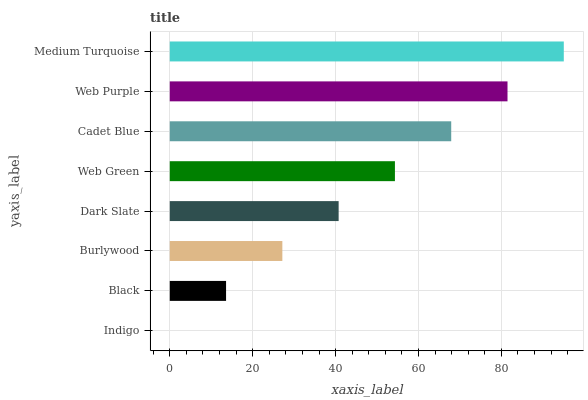Is Indigo the minimum?
Answer yes or no. Yes. Is Medium Turquoise the maximum?
Answer yes or no. Yes. Is Black the minimum?
Answer yes or no. No. Is Black the maximum?
Answer yes or no. No. Is Black greater than Indigo?
Answer yes or no. Yes. Is Indigo less than Black?
Answer yes or no. Yes. Is Indigo greater than Black?
Answer yes or no. No. Is Black less than Indigo?
Answer yes or no. No. Is Web Green the high median?
Answer yes or no. Yes. Is Dark Slate the low median?
Answer yes or no. Yes. Is Black the high median?
Answer yes or no. No. Is Medium Turquoise the low median?
Answer yes or no. No. 